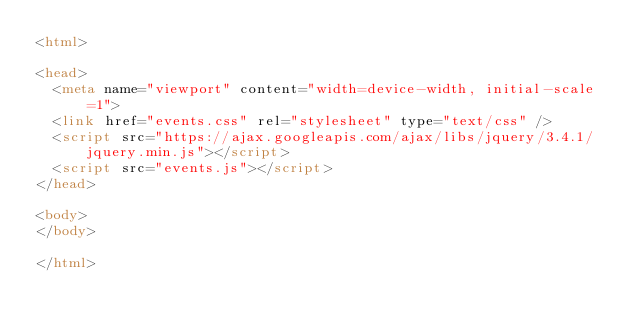<code> <loc_0><loc_0><loc_500><loc_500><_HTML_><html>

<head>
  <meta name="viewport" content="width=device-width, initial-scale=1">
  <link href="events.css" rel="stylesheet" type="text/css" />
  <script src="https://ajax.googleapis.com/ajax/libs/jquery/3.4.1/jquery.min.js"></script>
  <script src="events.js"></script>
</head>

<body>
</body>

</html></code> 